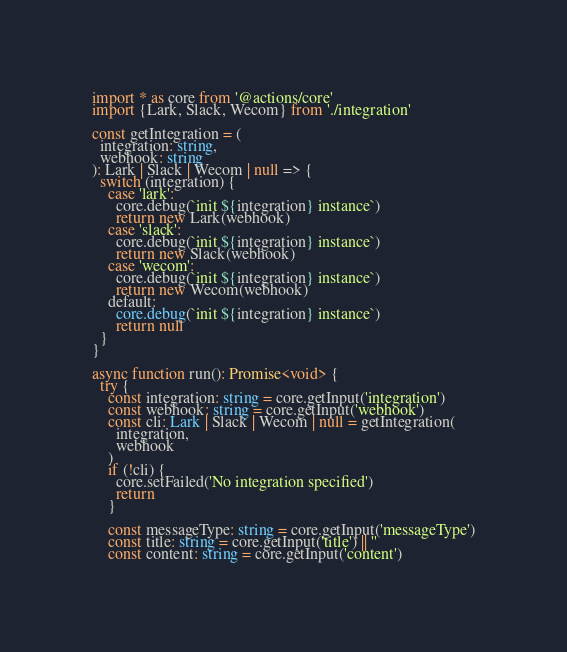Convert code to text. <code><loc_0><loc_0><loc_500><loc_500><_TypeScript_>import * as core from '@actions/core'
import {Lark, Slack, Wecom} from './integration'

const getIntegration = (
  integration: string,
  webhook: string
): Lark | Slack | Wecom | null => {
  switch (integration) {
    case 'lark':
      core.debug(`init ${integration} instance`)
      return new Lark(webhook)
    case 'slack':
      core.debug(`init ${integration} instance`)
      return new Slack(webhook)
    case 'wecom':
      core.debug(`init ${integration} instance`)
      return new Wecom(webhook)
    default:
      core.debug(`init ${integration} instance`)
      return null
  }
}

async function run(): Promise<void> {
  try {
    const integration: string = core.getInput('integration')
    const webhook: string = core.getInput('webhook')
    const cli: Lark | Slack | Wecom | null = getIntegration(
      integration,
      webhook
    )
    if (!cli) {
      core.setFailed('No integration specified')
      return
    }

    const messageType: string = core.getInput('messageType')
    const title: string = core.getInput('title') || ''
    const content: string = core.getInput('content')</code> 